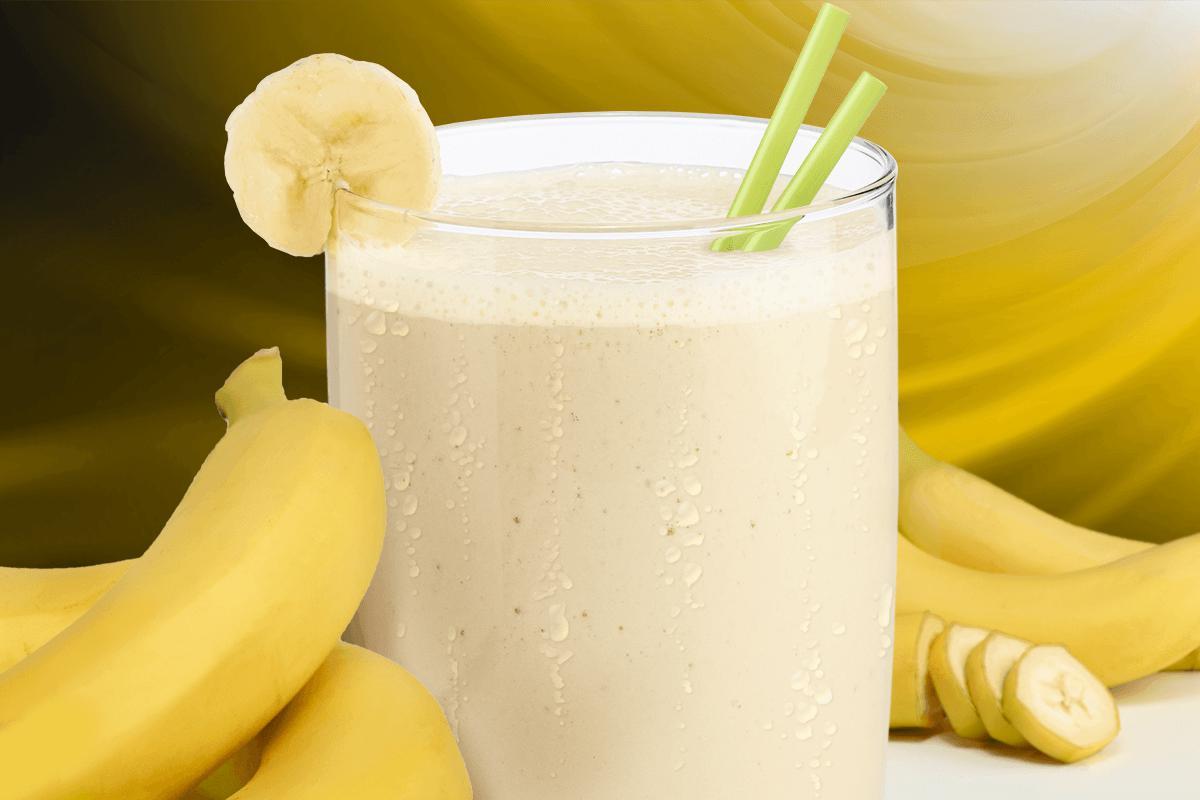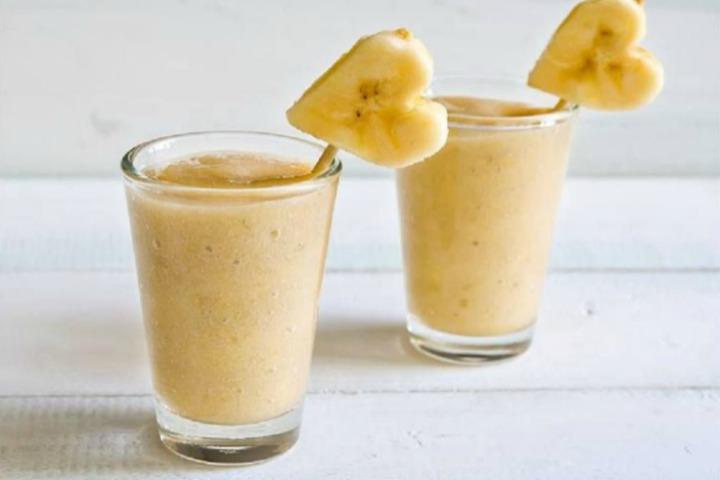The first image is the image on the left, the second image is the image on the right. Analyze the images presented: Is the assertion "All images include unpeeled bananas, and one image includes a brown drink garnished with a slice of banana, while the other image includes a glass with something bright yellow sticking out of the top." valid? Answer yes or no. No. The first image is the image on the left, the second image is the image on the right. Given the left and right images, does the statement "there is a glass with at least one straw in it" hold true? Answer yes or no. Yes. 